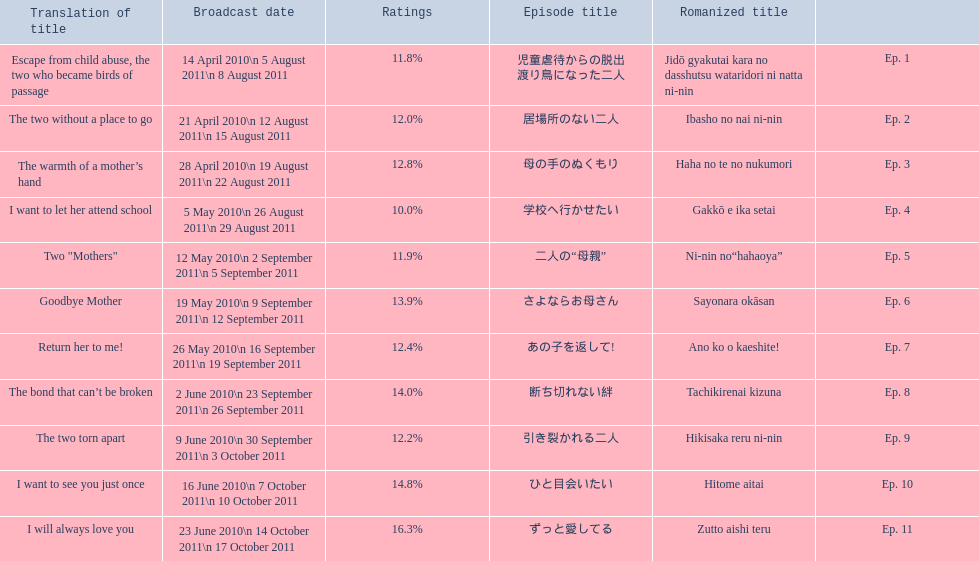Which episode was titled the two without a place to go? Ep. 2. What was the title of ep. 3? The warmth of a mother’s hand. Which episode had a rating of 10.0%? Ep. 4. 